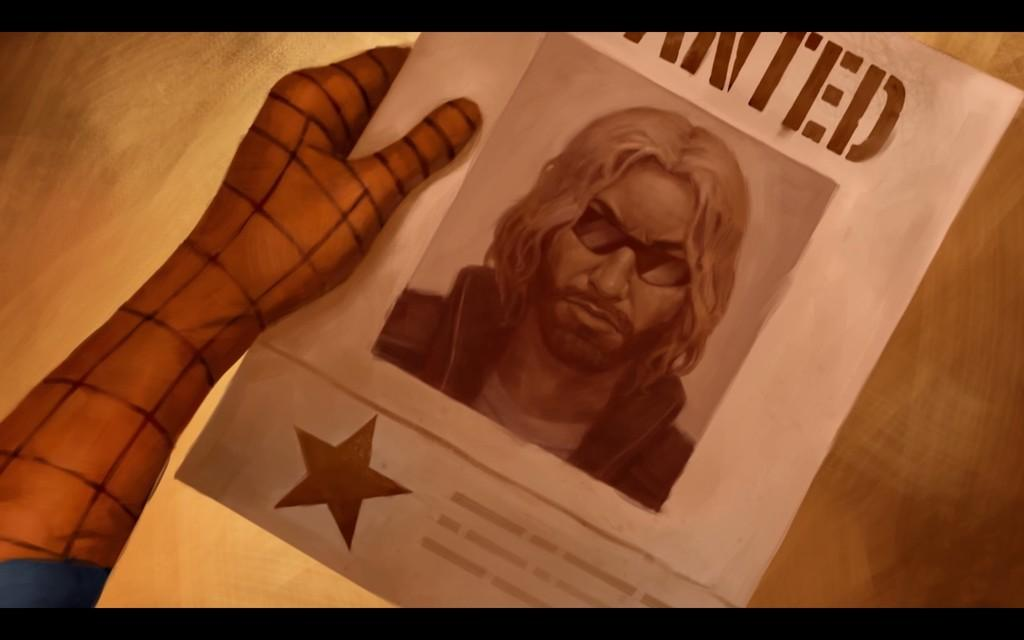<image>
Describe the image concisely. Spiderman holding a poster that says Wanted in his hand. 